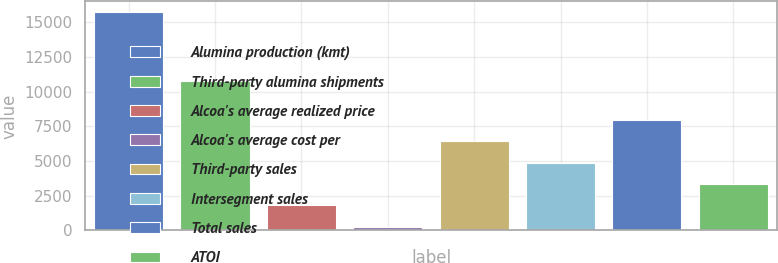Convert chart. <chart><loc_0><loc_0><loc_500><loc_500><bar_chart><fcel>Alumina production (kmt)<fcel>Third-party alumina shipments<fcel>Alcoa's average realized price<fcel>Alcoa's average cost per<fcel>Third-party sales<fcel>Intersegment sales<fcel>Total sales<fcel>ATOI<nl><fcel>15720<fcel>10755<fcel>1785.3<fcel>237<fcel>6430.2<fcel>4881.9<fcel>7978.5<fcel>3333.6<nl></chart> 